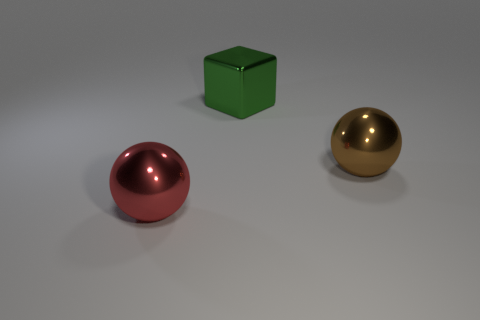Subtract all brown spheres. How many yellow blocks are left? 0 Subtract all big green metallic blocks. Subtract all large brown objects. How many objects are left? 1 Add 1 large green shiny blocks. How many large green shiny blocks are left? 2 Add 1 tiny gray metal cubes. How many tiny gray metal cubes exist? 1 Add 1 big brown metallic spheres. How many objects exist? 4 Subtract all red spheres. How many spheres are left? 1 Subtract 0 cyan cylinders. How many objects are left? 3 Subtract all spheres. How many objects are left? 1 Subtract 1 balls. How many balls are left? 1 Subtract all brown cubes. Subtract all yellow balls. How many cubes are left? 1 